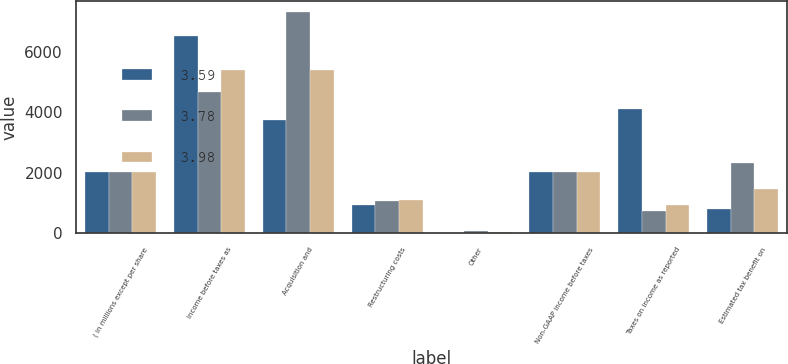<chart> <loc_0><loc_0><loc_500><loc_500><stacked_bar_chart><ecel><fcel>( in millions except per share<fcel>Income before taxes as<fcel>Acquisition and<fcel>Restructuring costs<fcel>Other<fcel>Non-GAAP income before taxes<fcel>Taxes on income as reported<fcel>Estimated tax benefit on<nl><fcel>3.59<fcel>2017<fcel>6521<fcel>3760<fcel>927<fcel>16<fcel>2015<fcel>4103<fcel>785<nl><fcel>3.78<fcel>2016<fcel>4659<fcel>7312<fcel>1069<fcel>67<fcel>2015<fcel>718<fcel>2321<nl><fcel>3.98<fcel>2015<fcel>5401<fcel>5398<fcel>1110<fcel>34<fcel>2015<fcel>942<fcel>1470<nl></chart> 